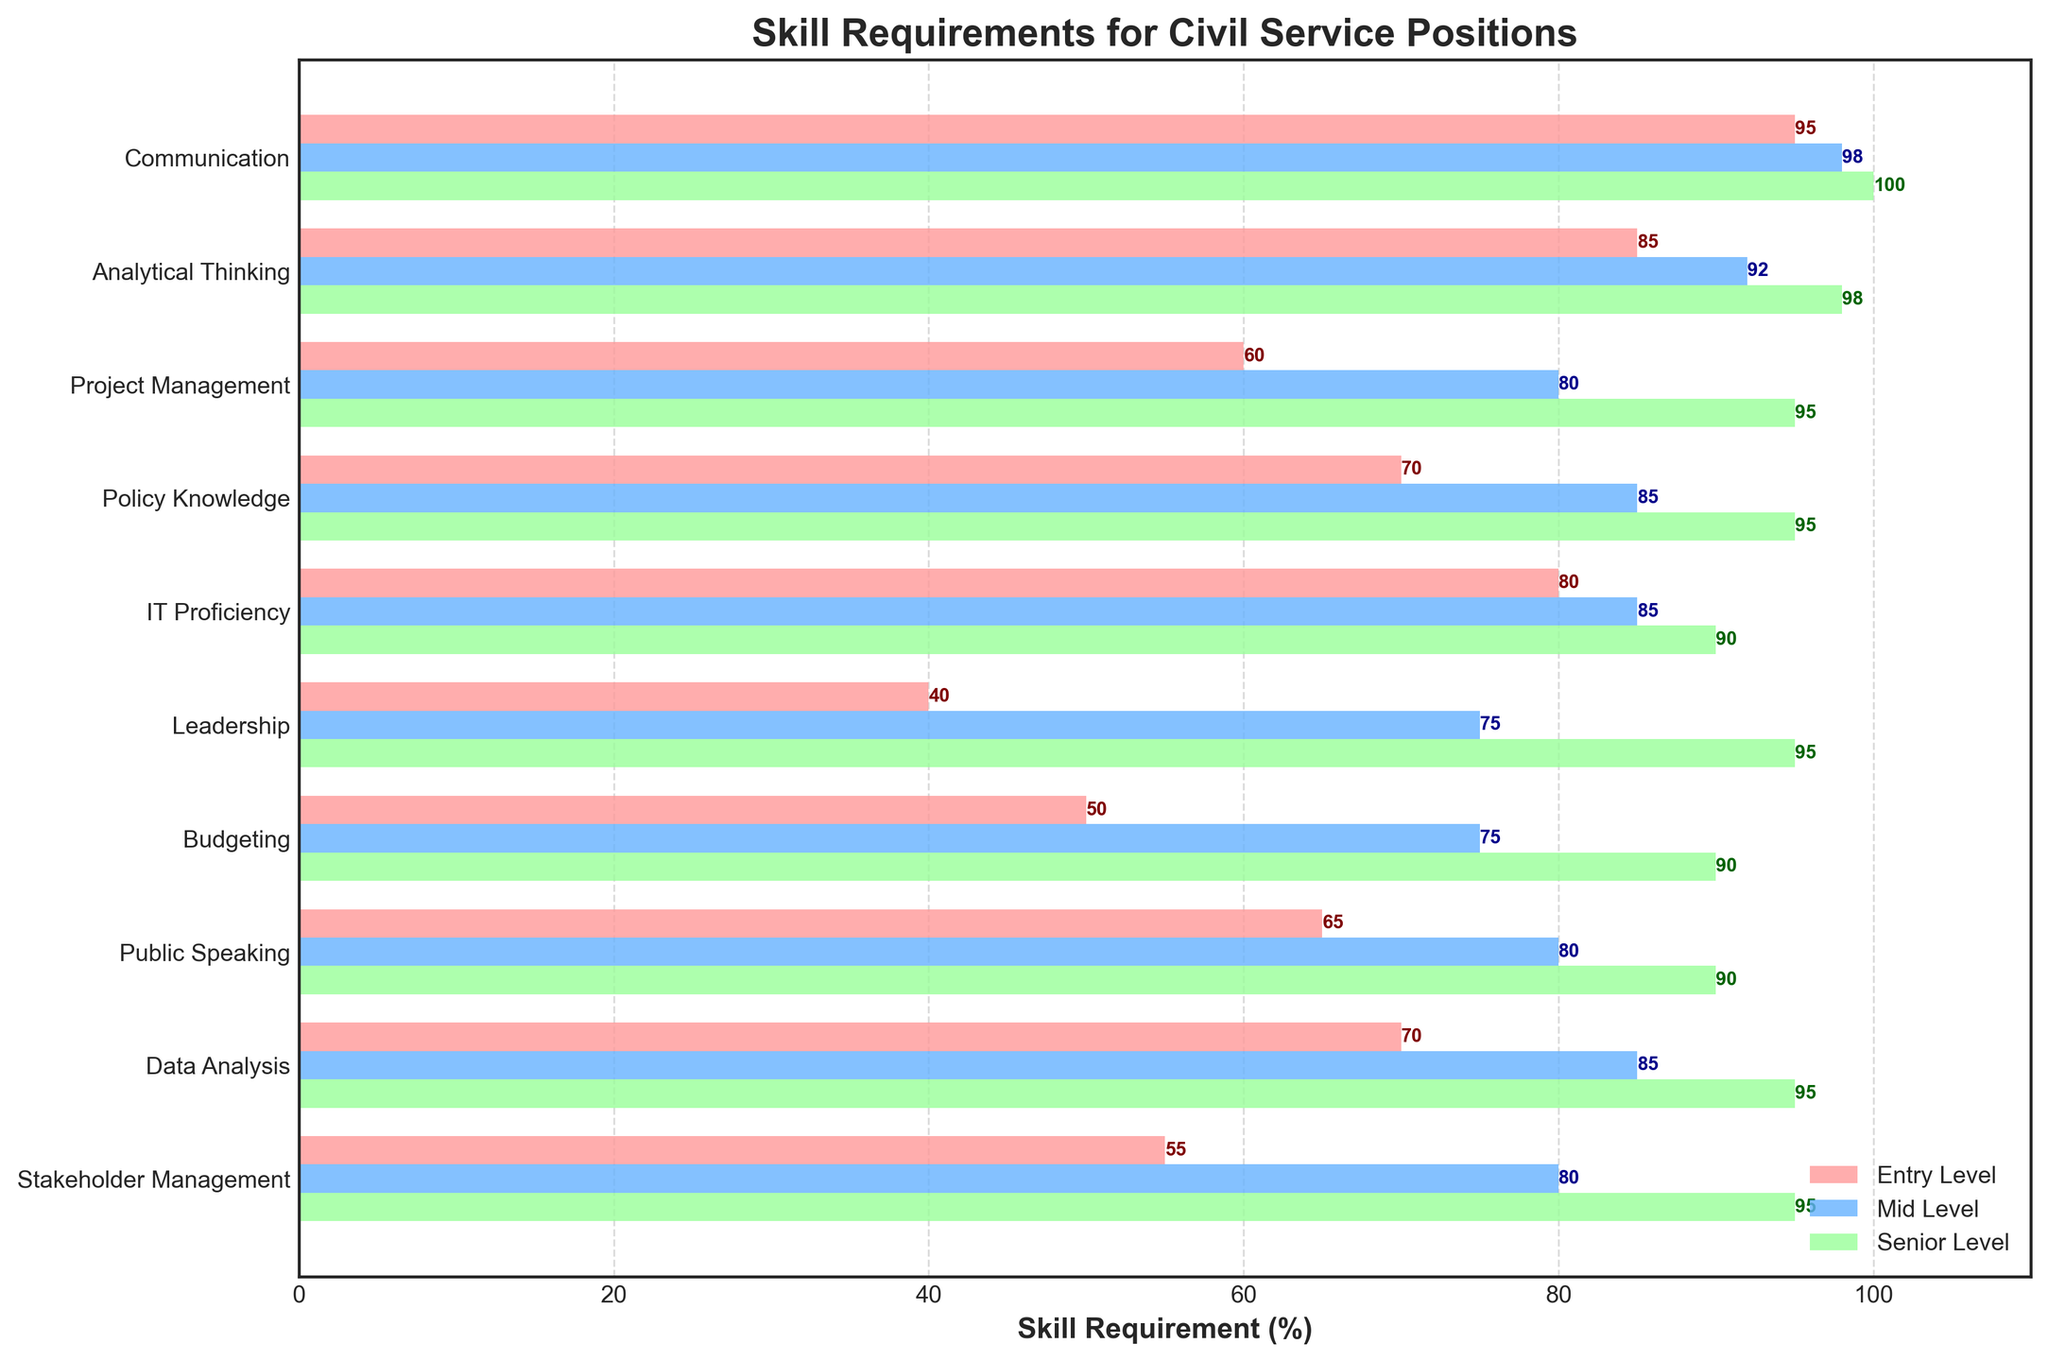What is the title of the figure? The title is usually found at the top of the figure. In this case, the title is "Skill Requirements for Civil Service Positions".
Answer: Skill Requirements for Civil Service Positions Which skill has the highest requirement for Senior Level positions? Examine the Senior Level skill bars. The highest value, which reaches 100%, corresponds to the skill "Communication".
Answer: Communication How much higher is the requirement for IT Proficiency from Entry Level to Senior Level? Look at the IT Proficiency values: Entry Level is 80%, Senior Level is 90%. The difference is calculated as 90% - 80%.
Answer: 10% What is the average skill requirement percentage for Entry Level positions? Sum all the Entry Level percentages and divide by the number of skills: (95 + 85 + 60 + 70 + 80 + 40 + 50 + 65 + 70 + 55) / 10 = 67%.
Answer: 67% Which skills have the same requirement for Mid Level and Senior Level positions? Compare Mid Level and Senior Level values for each skill. "IT Proficiency" and "Budgeting" both have Equal values of 85% for Mid Level and 90% for Senior Level.
Answer: IT Proficiency, Budgeting What is the smallest increase in skill requirement from Mid Level to Senior Level? Compare the increments for all skills from Mid Level to Senior Level. The smallest increase is for "IT Proficiency" from 85% to 90%, which is 5%.
Answer: 5% Which skill increases the most in requirement when moving from Entry Level to Mid Level? Compare the increments for all skills from Entry Level to Mid Level. "Leadership" increases the most, from 40% to 75%, which is an increase of 35%.
Answer: Leadership Are there any skills that reach 100% requirement, and at which level? By examining all bars, "Communication" reaches 100% at the Senior Level.
Answer: Yes, Communication at Senior Level How many skills have a requirement of 90% or higher for Senior Level positions? Count the Senior Level bars that are at or above 90%. These skills are "Communication", "Analytical Thinking", "Project Management", "Policy Knowledge", "Leadership", "Budgeting", "Public Speaking", "Data Analysis", and "Stakeholder Management", totaling 9.
Answer: 9 Which skill shows the most consistent increase across all levels? Assess the increase of each skill from Entry Level to Senior Level. The skill with the most consistent increase is "Analytical Thinking" with increments of 85%, 92%, and 98%.
Answer: Analytical Thinking 